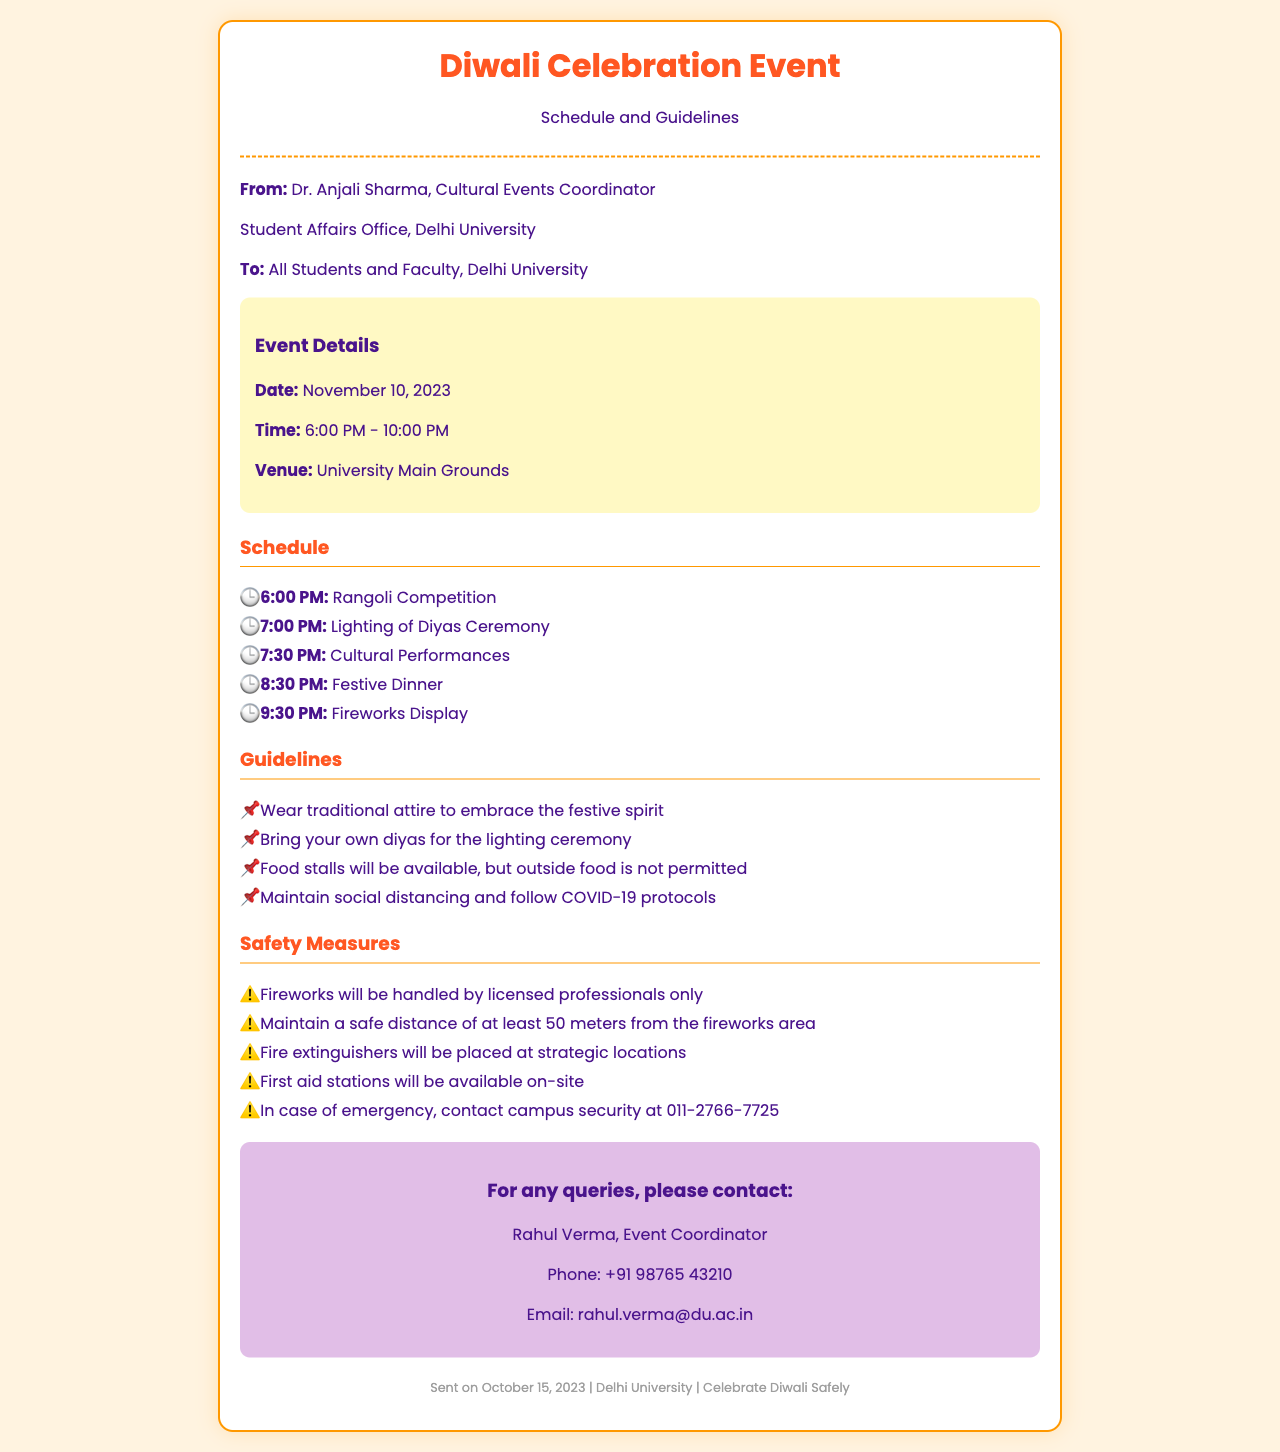What is the date of the event? The date of the event is explicitly stated in the event details section of the document.
Answer: November 10, 2023 What time does the fireworks display start? The time of the fireworks display is included in the schedule of the document.
Answer: 9:30 PM Who is the sender of the fax? The sender's name and title are provided at the beginning of the document.
Answer: Dr. Anjali Sharma What is required to participate in the lighting ceremony? The guidelines mention a specific requirement for the lighting ceremony.
Answer: Bring your own diyas Who will handle the fireworks? The safety measures section specifies who is responsible for handling the fireworks.
Answer: Licensed professionals What should attendees wear to the event? The guidelines provide specific advice on attire for attendees.
Answer: Traditional attire What is the contact number for campus security? The emergency contact number is listed in the safety measures section.
Answer: 011-2766-7725 How will food be managed at the event? The guidelines address food policies during the event.
Answer: Food stalls available; outside food not permitted What type of performances will take place? The schedule outlines the types of activities planned for the event.
Answer: Cultural Performances 